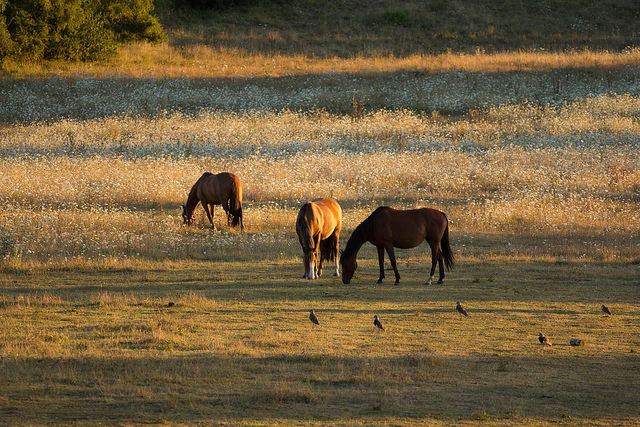<image>Are the horses thoroughbred? I don't know if the horses are thoroughbred. It can be either yes or no. Are the horses thoroughbred? I don't know if the horses are thoroughbred. It can be both yes and no. 